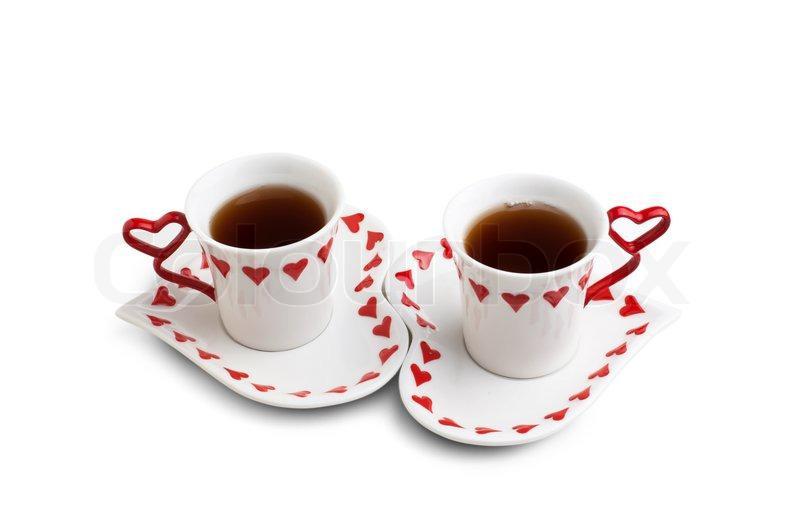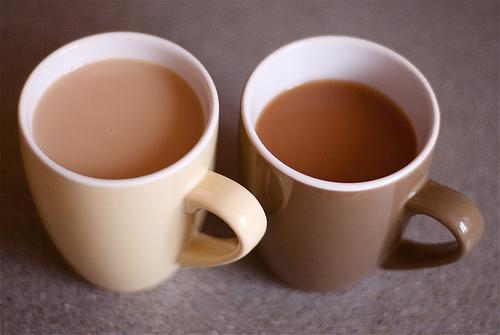The first image is the image on the left, the second image is the image on the right. For the images displayed, is the sentence "An image shows a white pitcher next to at least one filled mug on a saucer." factually correct? Answer yes or no. No. 